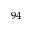Convert formula to latex. <formula><loc_0><loc_0><loc_500><loc_500>^ { 9 4 }</formula> 